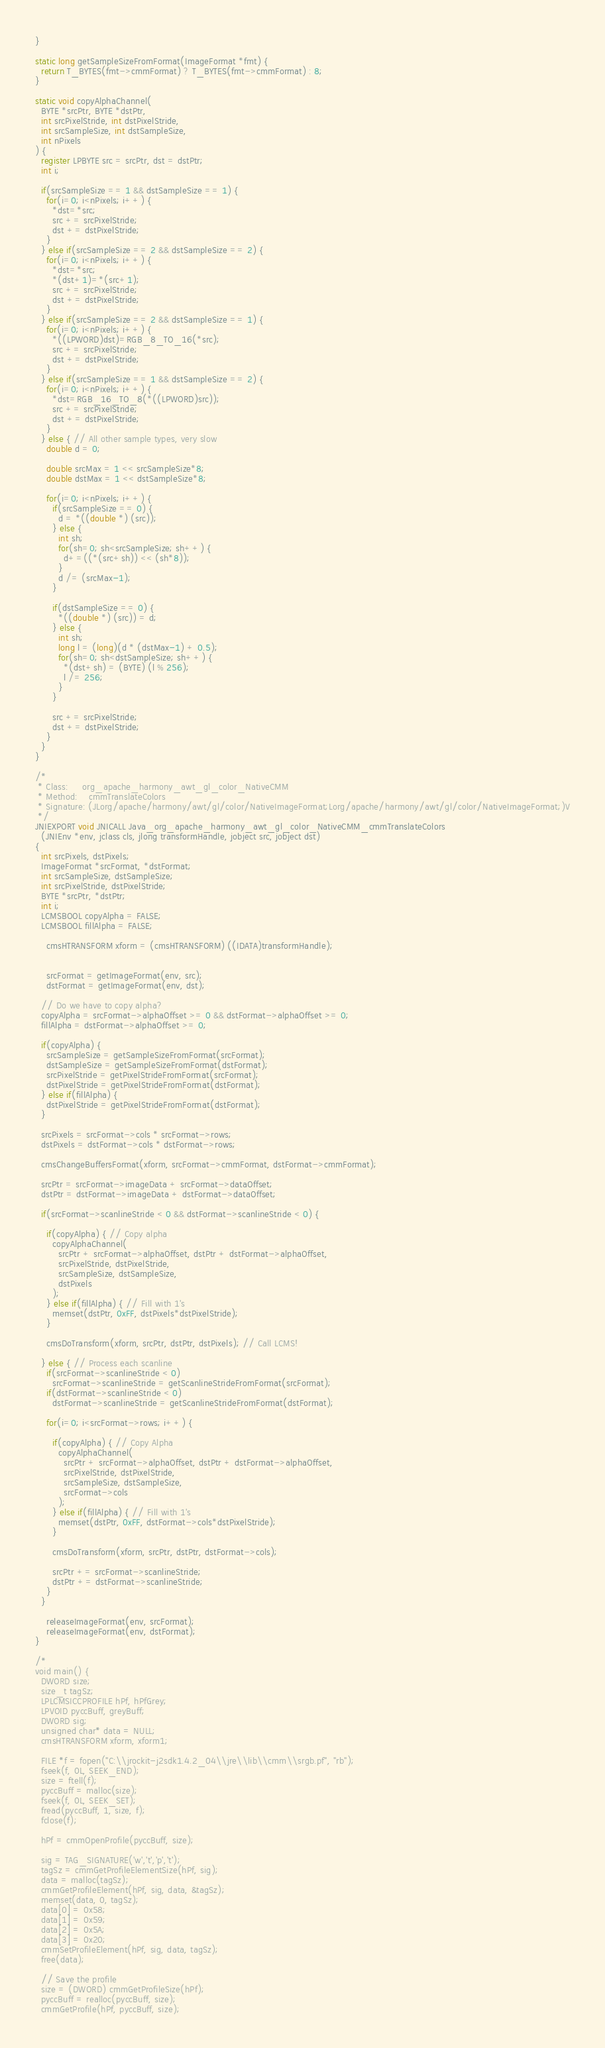Convert code to text. <code><loc_0><loc_0><loc_500><loc_500><_C_>}

static long getSampleSizeFromFormat(ImageFormat *fmt) {
  return T_BYTES(fmt->cmmFormat) ? T_BYTES(fmt->cmmFormat) : 8;
}

static void copyAlphaChannel(
  BYTE *srcPtr, BYTE *dstPtr, 
  int srcPixelStride, int dstPixelStride, 
  int srcSampleSize, int dstSampleSize,
  int nPixels
) {
  register LPBYTE src = srcPtr, dst = dstPtr;
  int i;

  if(srcSampleSize == 1 && dstSampleSize == 1) {
    for(i=0; i<nPixels; i++) {
      *dst=*src;
      src += srcPixelStride;
      dst += dstPixelStride;
    }
  } else if(srcSampleSize == 2 && dstSampleSize == 2) {
    for(i=0; i<nPixels; i++) {      
      *dst=*src;
      *(dst+1)=*(src+1);
      src += srcPixelStride;
      dst += dstPixelStride;
    }
  } else if(srcSampleSize == 2 && dstSampleSize == 1) {
    for(i=0; i<nPixels; i++) {
      *((LPWORD)dst)=RGB_8_TO_16(*src);
      src += srcPixelStride;
      dst += dstPixelStride;
    }
  } else if(srcSampleSize == 1 && dstSampleSize == 2) {
    for(i=0; i<nPixels; i++) {
      *dst=RGB_16_TO_8(*((LPWORD)src));
      src += srcPixelStride;
      dst += dstPixelStride;
    }
  } else { // All other sample types, very slow
    double d = 0;
    
    double srcMax = 1 << srcSampleSize*8;
    double dstMax = 1 << dstSampleSize*8;

    for(i=0; i<nPixels; i++) {
      if(srcSampleSize == 0) {
        d = *((double *) (src));
      } else {
        int sh;
        for(sh=0; sh<srcSampleSize; sh++) {
          d+=((*(src+sh)) << (sh*8));
        }
        d /= (srcMax-1);        
      }

      if(dstSampleSize == 0) {
        *((double *) (src)) = d;
      } else {
        int sh;
        long l = (long)(d * (dstMax-1) + 0.5);        
        for(sh=0; sh<dstSampleSize; sh++) {
          *(dst+sh) = (BYTE) (l % 256);
          l /= 256;
        }        
      }

      src += srcPixelStride;
      dst += dstPixelStride;
    }
  }
}

/*
 * Class:     org_apache_harmony_awt_gl_color_NativeCMM
 * Method:    cmmTranslateColors
 * Signature: (JLorg/apache/harmony/awt/gl/color/NativeImageFormat;Lorg/apache/harmony/awt/gl/color/NativeImageFormat;)V
 */ 
JNIEXPORT void JNICALL Java_org_apache_harmony_awt_gl_color_NativeCMM_cmmTranslateColors
  (JNIEnv *env, jclass cls, jlong transformHandle, jobject src, jobject dst)
{
  int srcPixels, dstPixels;
  ImageFormat *srcFormat, *dstFormat;
  int srcSampleSize, dstSampleSize;
  int srcPixelStride, dstPixelStride;
  BYTE *srcPtr, *dstPtr;
  int i;
  LCMSBOOL copyAlpha = FALSE;
  LCMSBOOL fillAlpha = FALSE;

    cmsHTRANSFORM xform = (cmsHTRANSFORM) ((IDATA)transformHandle);


    srcFormat = getImageFormat(env, src);
    dstFormat = getImageFormat(env, dst);

  // Do we have to copy alpha?
  copyAlpha = srcFormat->alphaOffset >= 0 && dstFormat->alphaOffset >= 0;
  fillAlpha = dstFormat->alphaOffset >= 0;

  if(copyAlpha) {
    srcSampleSize = getSampleSizeFromFormat(srcFormat);
    dstSampleSize = getSampleSizeFromFormat(dstFormat);
    srcPixelStride = getPixelStrideFromFormat(srcFormat);
    dstPixelStride = getPixelStrideFromFormat(dstFormat);
  } else if(fillAlpha) {
    dstPixelStride = getPixelStrideFromFormat(dstFormat);
  }

  srcPixels = srcFormat->cols * srcFormat->rows;
  dstPixels = dstFormat->cols * dstFormat->rows;
  
  cmsChangeBuffersFormat(xform, srcFormat->cmmFormat, dstFormat->cmmFormat);

  srcPtr = srcFormat->imageData + srcFormat->dataOffset;
  dstPtr = dstFormat->imageData + dstFormat->dataOffset;
  
  if(srcFormat->scanlineStride < 0 && dstFormat->scanlineStride < 0) {
    
    if(copyAlpha) { // Copy alpha
      copyAlphaChannel(
        srcPtr + srcFormat->alphaOffset, dstPtr + dstFormat->alphaOffset, 
        srcPixelStride, dstPixelStride, 
        srcSampleSize, dstSampleSize, 
        dstPixels
      ); 
    } else if(fillAlpha) { // Fill with 1's
      memset(dstPtr, 0xFF, dstPixels*dstPixelStride); 
    }

    cmsDoTransform(xform, srcPtr, dstPtr, dstPixels); // Call LCMS!

  } else { // Process each scanline
    if(srcFormat->scanlineStride < 0)
      srcFormat->scanlineStride = getScanlineStrideFromFormat(srcFormat);
    if(dstFormat->scanlineStride < 0)
      dstFormat->scanlineStride = getScanlineStrideFromFormat(dstFormat);

    for(i=0; i<srcFormat->rows; i++) {
      
      if(copyAlpha) { // Copy Alpha
        copyAlphaChannel(
          srcPtr + srcFormat->alphaOffset, dstPtr + dstFormat->alphaOffset, 
          srcPixelStride, dstPixelStride, 
          srcSampleSize, dstSampleSize, 
          srcFormat->cols
        ); 
      } else if(fillAlpha) { // Fill with 1's
        memset(dstPtr, 0xFF, dstFormat->cols*dstPixelStride); 
      }

      cmsDoTransform(xform, srcPtr, dstPtr, dstFormat->cols);

      srcPtr += srcFormat->scanlineStride;
      dstPtr += dstFormat->scanlineStride;
    }
  }

    releaseImageFormat(env, srcFormat);
    releaseImageFormat(env, dstFormat);
}

/*
void main() {
  DWORD size;
  size_t tagSz;
  LPLCMSICCPROFILE hPf, hPfGrey;
  LPVOID pyccBuff, greyBuff;
  DWORD sig;
  unsigned char* data = NULL;
  cmsHTRANSFORM xform, xform1;

  FILE *f = fopen("C:\\jrockit-j2sdk1.4.2_04\\jre\\lib\\cmm\\srgb.pf", "rb");
  fseek(f, 0L, SEEK_END);
  size = ftell(f);
  pyccBuff = malloc(size);
  fseek(f, 0L, SEEK_SET);
  fread(pyccBuff, 1, size, f);
  fclose(f);

  hPf = cmmOpenProfile(pyccBuff, size);
  
  sig = TAG_SIGNATURE('w','t','p','t');
  tagSz = cmmGetProfileElementSize(hPf, sig);
  data = malloc(tagSz);
  cmmGetProfileElement(hPf, sig, data, &tagSz);
  memset(data, 0, tagSz);
  data[0] = 0x58;
  data[1] = 0x59;
  data[2] = 0x5A;
  data[3] = 0x20;
  cmmSetProfileElement(hPf, sig, data, tagSz);
  free(data);

  // Save the profile
  size = (DWORD) cmmGetProfileSize(hPf);
  pyccBuff = realloc(pyccBuff, size);
  cmmGetProfile(hPf, pyccBuff, size);</code> 